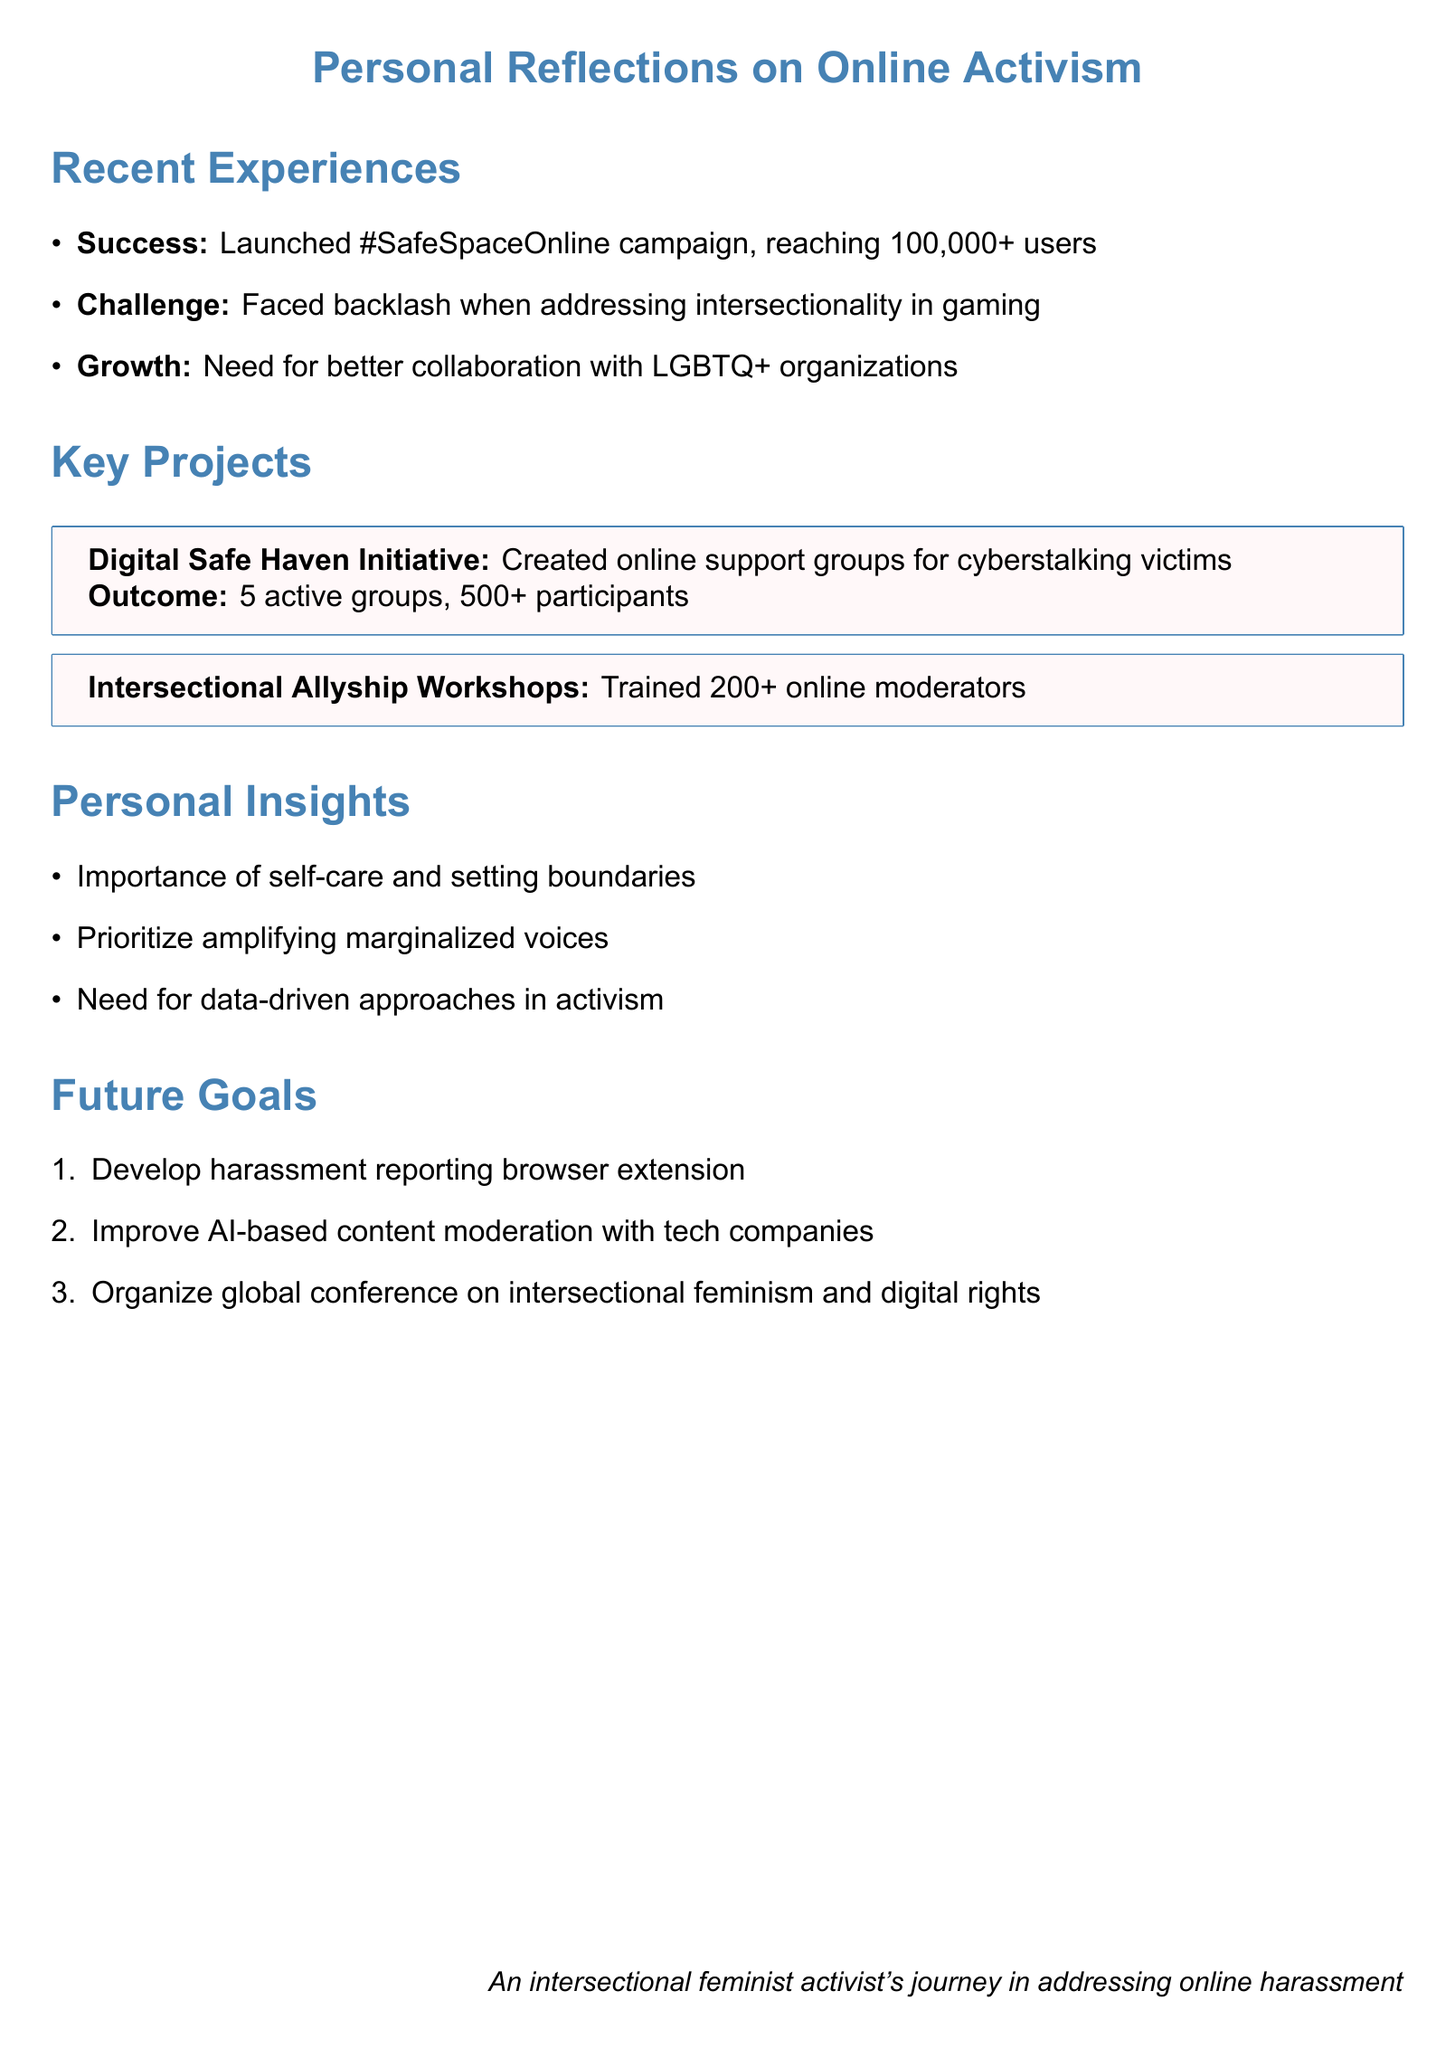what was the title of the campaign launched? The title of the campaign launched is mentioned in the success section of the document.
Answer: #SafeSpaceOnline how many users did the #SafeSpaceOnline campaign reach? The document specifies that the campaign reached a certain number of users in the success section.
Answer: over 100,000 users what percentage increase was reported for online harassment incidents? The percentage increase reported is noted in relation to the impact of the #SafeSpaceOnline campaign.
Answer: 30% which organizations are being considered for collaboration? The document lists specific organizations intended for potential partnerships in the growth area section.
Answer: GLAAD and The Trevor Project how many participants joined the Digital Safe Haven Initiative support groups? The number of participants is detailed in the outcome of the Digital Safe Haven Initiative project.
Answer: over 500 participants what was the outcome of the Intersectional Allyship Workshop Series? The outcome of the workshop series is mentioned in the key projects section of the document.
Answer: Trained 200+ online moderators what is a key insight regarding online activism? The document highlights insights gained from personal reflections on online activism.
Answer: importance of self-care what is one of the future goals mentioned? The document lists aspirations for future initiatives related to online activism.
Answer: Develop a browser extension to help users identify and report online harassment what does the document emphasize about the role of marginalized voices? The document stresses the importance of acknowledging and amplifying certain voices in its insights.
Answer: prioritizing amplifying marginalized voices how many active support groups were established in the Digital Safe Haven Initiative? The document specifically mentions the count of these groups under key projects.
Answer: 5 active support groups 